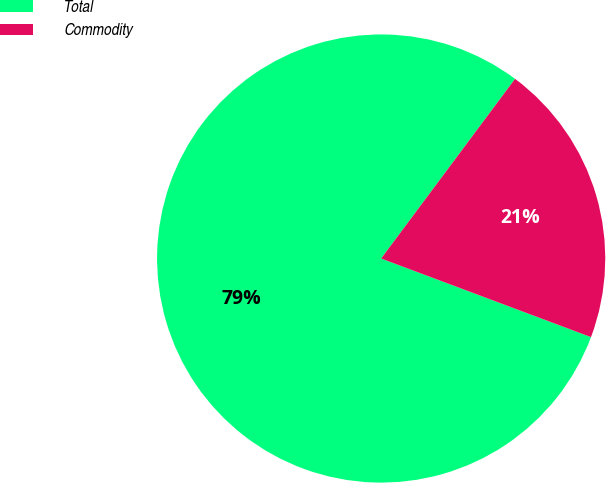<chart> <loc_0><loc_0><loc_500><loc_500><pie_chart><fcel>Total<fcel>Commodity<nl><fcel>79.49%<fcel>20.51%<nl></chart> 